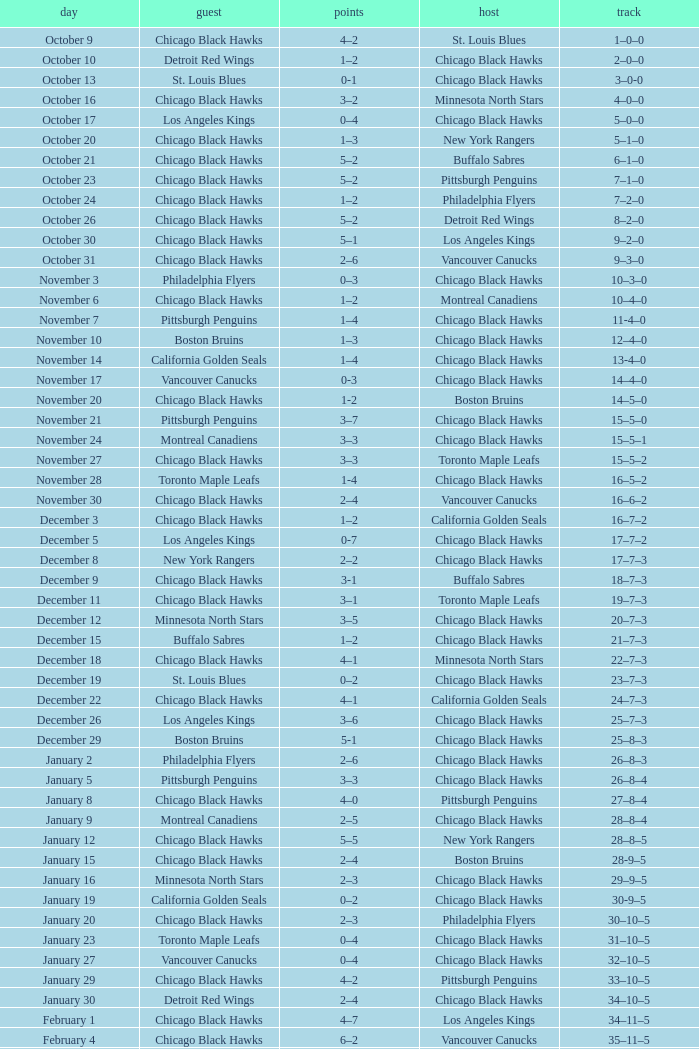Can you tell me the record for the date february 26? 39–16–7. 